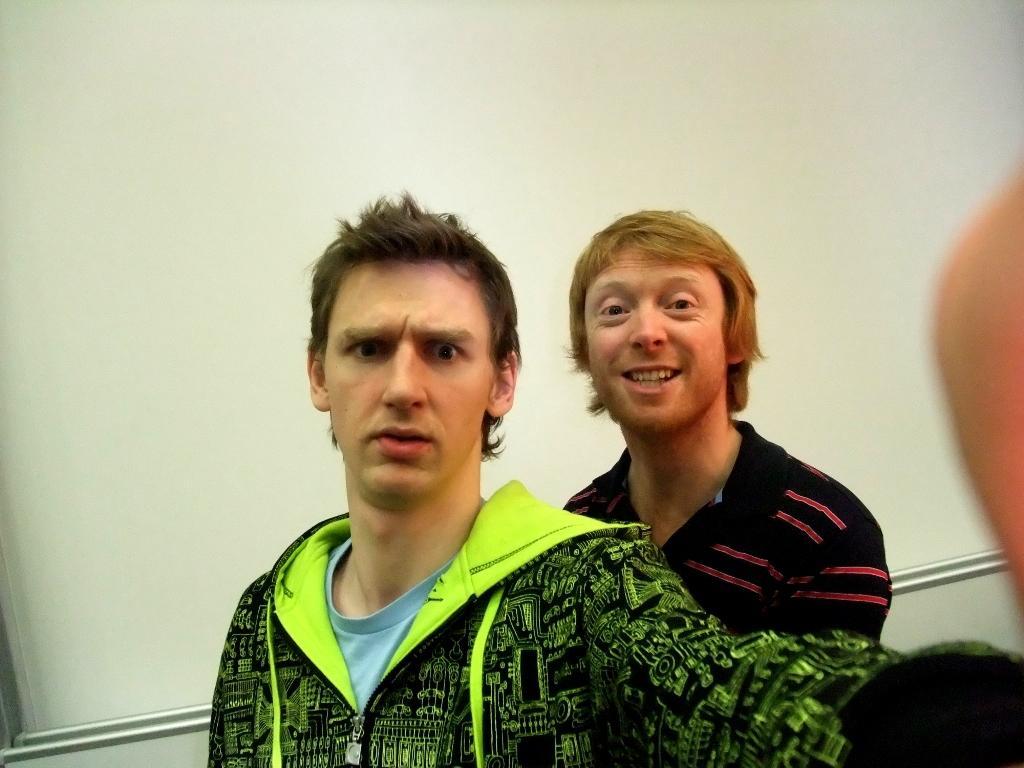In one or two sentences, can you explain what this image depicts? In this image I can see two men and I can see one of them is wearing a green colour jacket. Behind them I can see a white colour thing and on the right side of this image I can see and a blurry thing. 